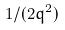<formula> <loc_0><loc_0><loc_500><loc_500>1 / ( 2 q ^ { 2 } )</formula> 